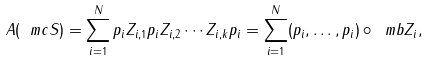<formula> <loc_0><loc_0><loc_500><loc_500>A ( \ m c { S } ) = \sum _ { i = 1 } ^ { N } p _ { i } Z _ { i , 1 } p _ { i } Z _ { i , 2 } \cdots Z _ { i , k } p _ { i } = \sum _ { i = 1 } ^ { N } ( p _ { i } , \dots , p _ { i } ) \circ \ m b { Z } _ { i } ,</formula> 